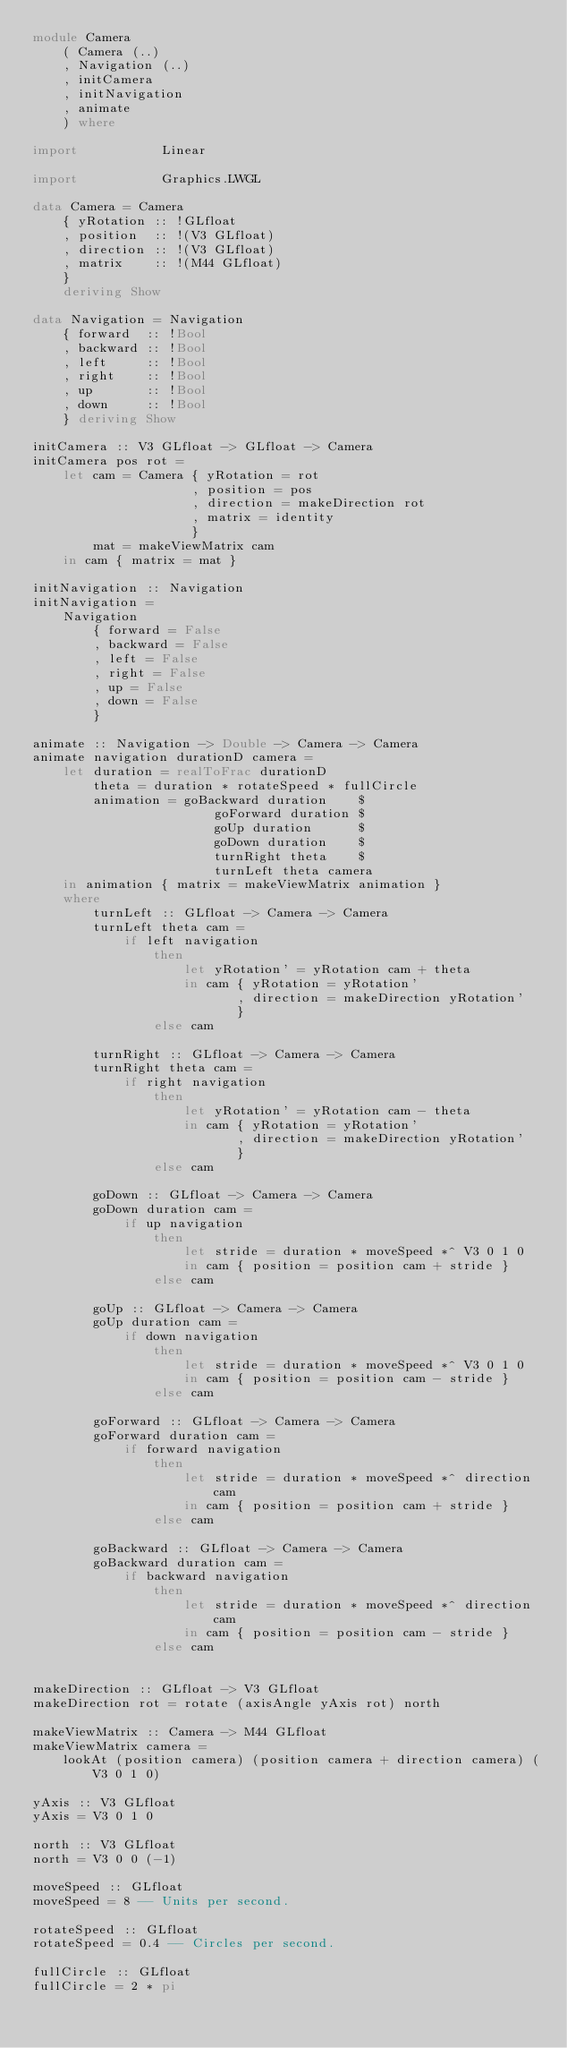Convert code to text. <code><loc_0><loc_0><loc_500><loc_500><_Haskell_>module Camera
    ( Camera (..)
    , Navigation (..)
    , initCamera
    , initNavigation
    , animate
    ) where

import           Linear

import           Graphics.LWGL

data Camera = Camera
    { yRotation :: !GLfloat
    , position  :: !(V3 GLfloat)
    , direction :: !(V3 GLfloat)
    , matrix    :: !(M44 GLfloat)
    }
    deriving Show

data Navigation = Navigation
    { forward  :: !Bool
    , backward :: !Bool
    , left     :: !Bool
    , right    :: !Bool
    , up       :: !Bool
    , down     :: !Bool
    } deriving Show

initCamera :: V3 GLfloat -> GLfloat -> Camera
initCamera pos rot =
    let cam = Camera { yRotation = rot
                     , position = pos
                     , direction = makeDirection rot
                     , matrix = identity
                     }
        mat = makeViewMatrix cam
    in cam { matrix = mat }

initNavigation :: Navigation
initNavigation =
    Navigation
        { forward = False
        , backward = False
        , left = False
        , right = False
        , up = False
        , down = False
        }

animate :: Navigation -> Double -> Camera -> Camera
animate navigation durationD camera =
    let duration = realToFrac durationD
        theta = duration * rotateSpeed * fullCircle
        animation = goBackward duration    $
                        goForward duration $
                        goUp duration      $
                        goDown duration    $
                        turnRight theta    $
                        turnLeft theta camera
    in animation { matrix = makeViewMatrix animation }
    where
        turnLeft :: GLfloat -> Camera -> Camera
        turnLeft theta cam =
            if left navigation
                then
                    let yRotation' = yRotation cam + theta
                    in cam { yRotation = yRotation'
                           , direction = makeDirection yRotation'
                           }
                else cam

        turnRight :: GLfloat -> Camera -> Camera
        turnRight theta cam =
            if right navigation
                then
                    let yRotation' = yRotation cam - theta
                    in cam { yRotation = yRotation'
                           , direction = makeDirection yRotation'
                           }
                else cam

        goDown :: GLfloat -> Camera -> Camera
        goDown duration cam =
            if up navigation
                then
                    let stride = duration * moveSpeed *^ V3 0 1 0
                    in cam { position = position cam + stride }
                else cam

        goUp :: GLfloat -> Camera -> Camera
        goUp duration cam =
            if down navigation
                then
                    let stride = duration * moveSpeed *^ V3 0 1 0
                    in cam { position = position cam - stride }
                else cam

        goForward :: GLfloat -> Camera -> Camera
        goForward duration cam =
            if forward navigation
                then
                    let stride = duration * moveSpeed *^ direction cam
                    in cam { position = position cam + stride }
                else cam

        goBackward :: GLfloat -> Camera -> Camera
        goBackward duration cam =
            if backward navigation
                then
                    let stride = duration * moveSpeed *^ direction cam
                    in cam { position = position cam - stride }
                else cam


makeDirection :: GLfloat -> V3 GLfloat
makeDirection rot = rotate (axisAngle yAxis rot) north

makeViewMatrix :: Camera -> M44 GLfloat
makeViewMatrix camera =
    lookAt (position camera) (position camera + direction camera) (V3 0 1 0)

yAxis :: V3 GLfloat
yAxis = V3 0 1 0

north :: V3 GLfloat
north = V3 0 0 (-1)

moveSpeed :: GLfloat
moveSpeed = 8 -- Units per second.

rotateSpeed :: GLfloat
rotateSpeed = 0.4 -- Circles per second.

fullCircle :: GLfloat
fullCircle = 2 * pi
</code> 